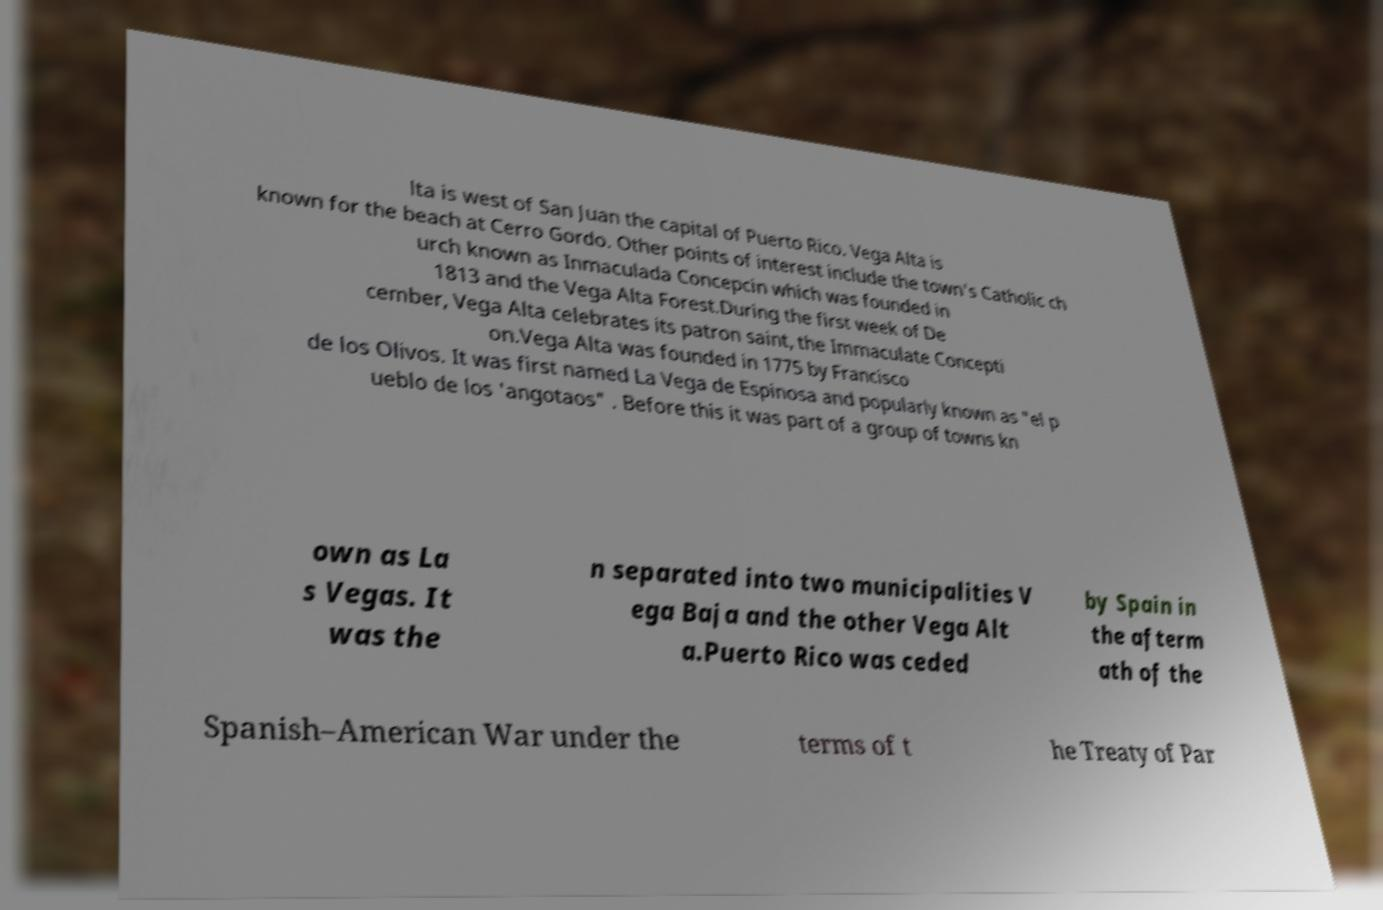There's text embedded in this image that I need extracted. Can you transcribe it verbatim? lta is west of San Juan the capital of Puerto Rico. Vega Alta is known for the beach at Cerro Gordo. Other points of interest include the town's Catholic ch urch known as Inmaculada Concepcin which was founded in 1813 and the Vega Alta Forest.During the first week of De cember, Vega Alta celebrates its patron saint, the Immaculate Concepti on.Vega Alta was founded in 1775 by Francisco de los Olivos. It was first named La Vega de Espinosa and popularly known as "el p ueblo de los 'angotaos" . Before this it was part of a group of towns kn own as La s Vegas. It was the n separated into two municipalities V ega Baja and the other Vega Alt a.Puerto Rico was ceded by Spain in the afterm ath of the Spanish–American War under the terms of t he Treaty of Par 